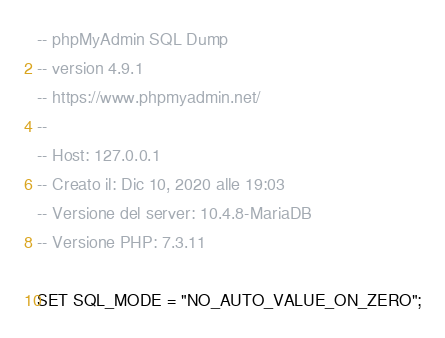<code> <loc_0><loc_0><loc_500><loc_500><_SQL_>-- phpMyAdmin SQL Dump
-- version 4.9.1
-- https://www.phpmyadmin.net/
--
-- Host: 127.0.0.1
-- Creato il: Dic 10, 2020 alle 19:03
-- Versione del server: 10.4.8-MariaDB
-- Versione PHP: 7.3.11

SET SQL_MODE = "NO_AUTO_VALUE_ON_ZERO";</code> 